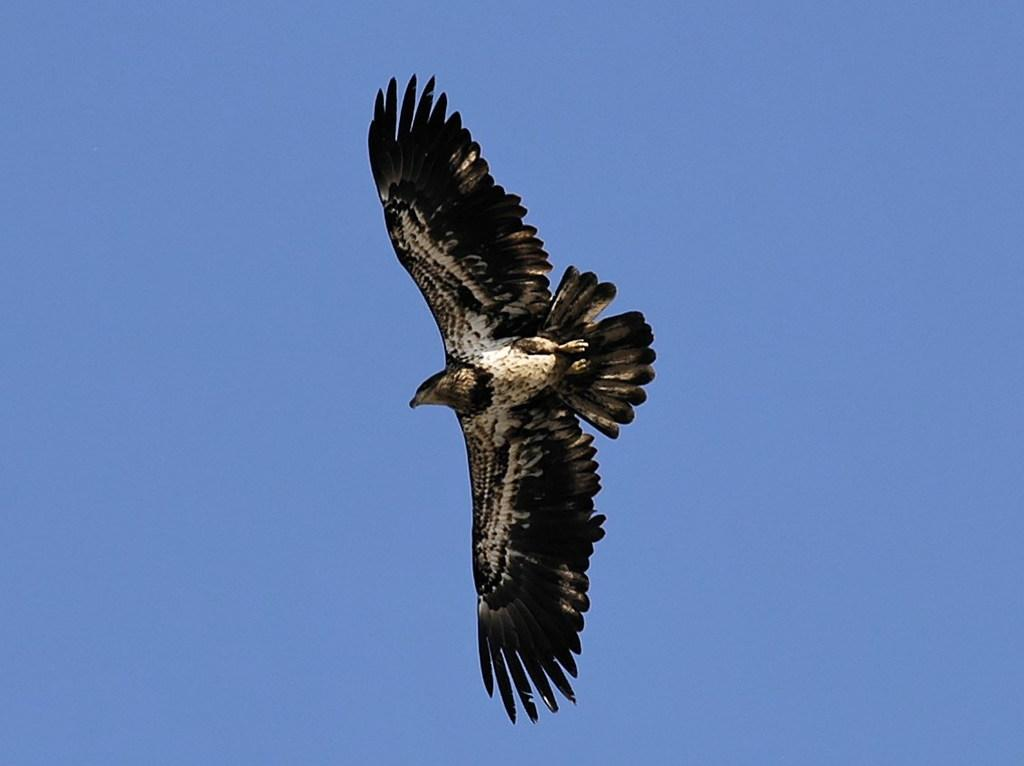What type of animal is in the image? There is a bird in the image. What colors can be seen on the bird? The bird has black, white, and brown colors. What is the bird doing in the image? The bird is flying in the air. What can be seen in the background of the image? The sky is visible in the background of the image. What type of religion is being practiced by the cattle in the image? There are no cattle present in the image, and therefore no religious practices can be observed. 